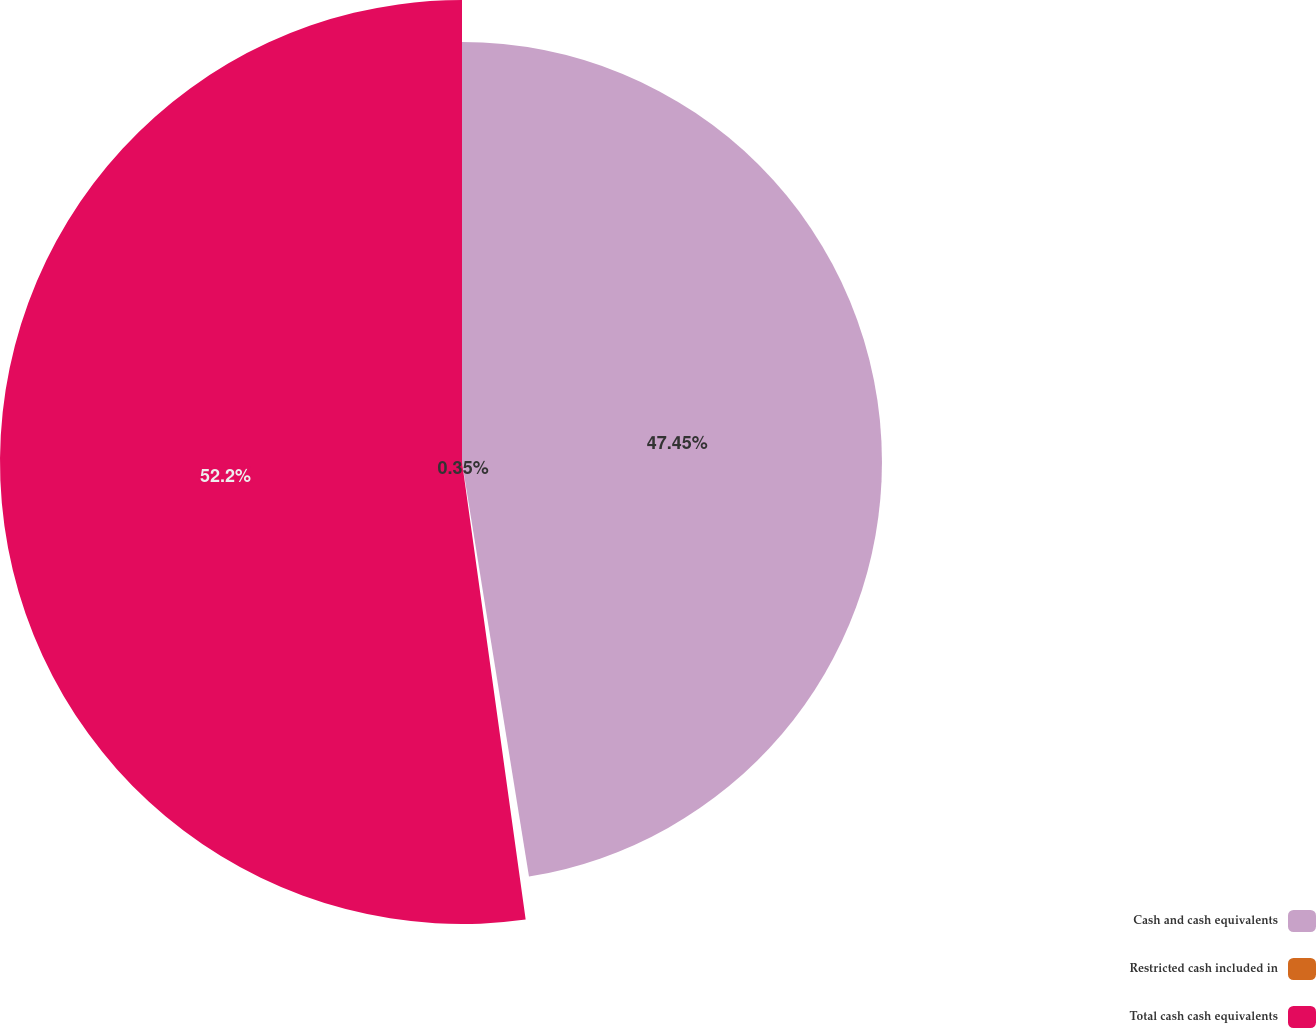Convert chart. <chart><loc_0><loc_0><loc_500><loc_500><pie_chart><fcel>Cash and cash equivalents<fcel>Restricted cash included in<fcel>Total cash cash equivalents<nl><fcel>47.45%<fcel>0.35%<fcel>52.2%<nl></chart> 